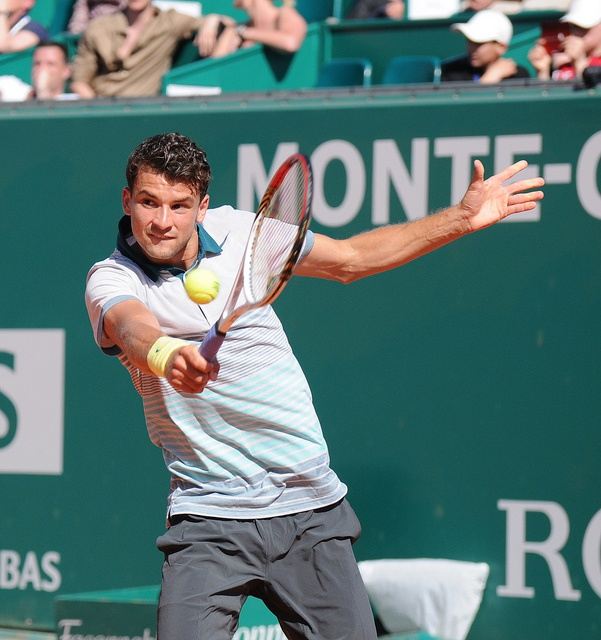Describe the objects in this image and their specific colors. I can see people in lightgray, white, gray, black, and salmon tones, people in lightgray, tan, and gray tones, tennis racket in lightgray, darkgray, gray, and brown tones, people in lightgray, white, black, tan, and brown tones, and people in lightgray, lightpink, white, brown, and tan tones in this image. 